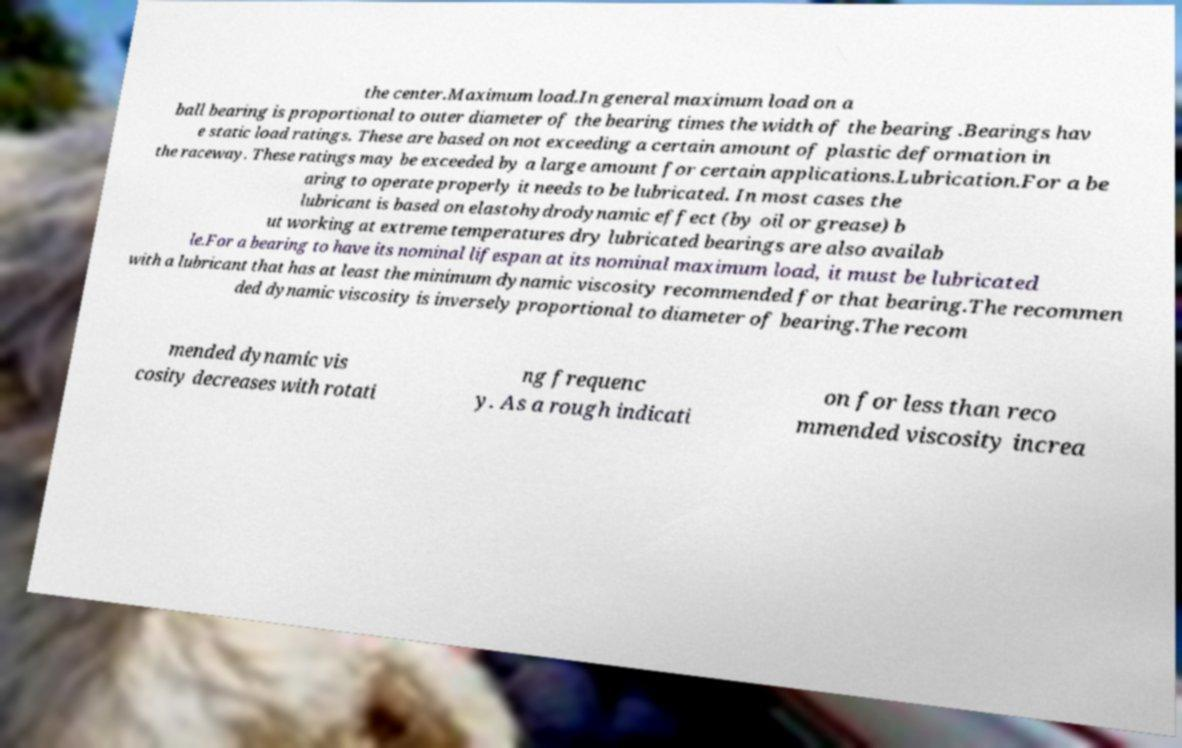Please identify and transcribe the text found in this image. the center.Maximum load.In general maximum load on a ball bearing is proportional to outer diameter of the bearing times the width of the bearing .Bearings hav e static load ratings. These are based on not exceeding a certain amount of plastic deformation in the raceway. These ratings may be exceeded by a large amount for certain applications.Lubrication.For a be aring to operate properly it needs to be lubricated. In most cases the lubricant is based on elastohydrodynamic effect (by oil or grease) b ut working at extreme temperatures dry lubricated bearings are also availab le.For a bearing to have its nominal lifespan at its nominal maximum load, it must be lubricated with a lubricant that has at least the minimum dynamic viscosity recommended for that bearing.The recommen ded dynamic viscosity is inversely proportional to diameter of bearing.The recom mended dynamic vis cosity decreases with rotati ng frequenc y. As a rough indicati on for less than reco mmended viscosity increa 